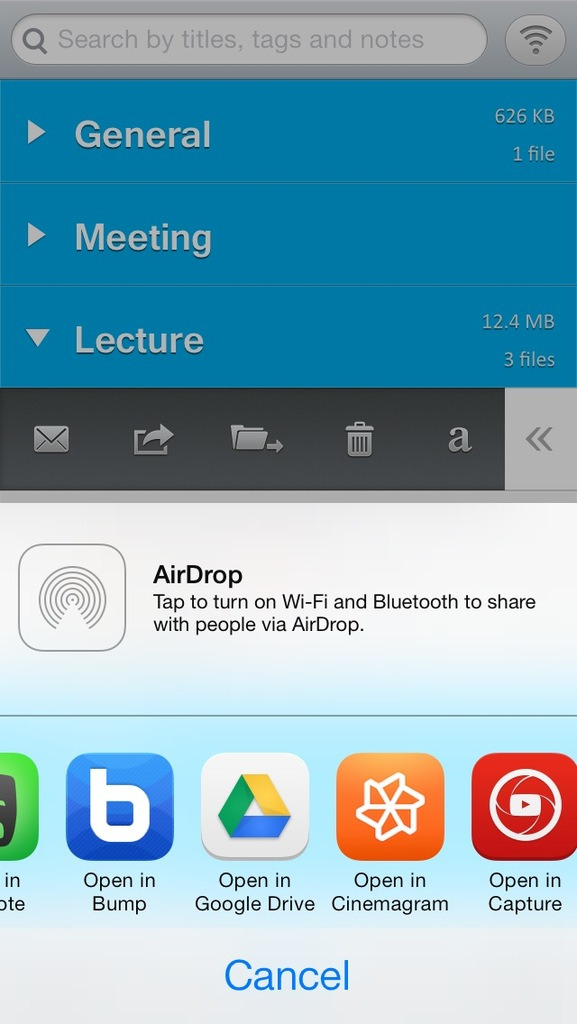How can files be shared from this screen, according to the options visible in the image? Files can be shared directly via AirDrop by enabling Wi-Fi and Bluetooth, or through other available apps like Google Drive, Bump, and Open in apps for specific functions listed at the bottom of the screen. 